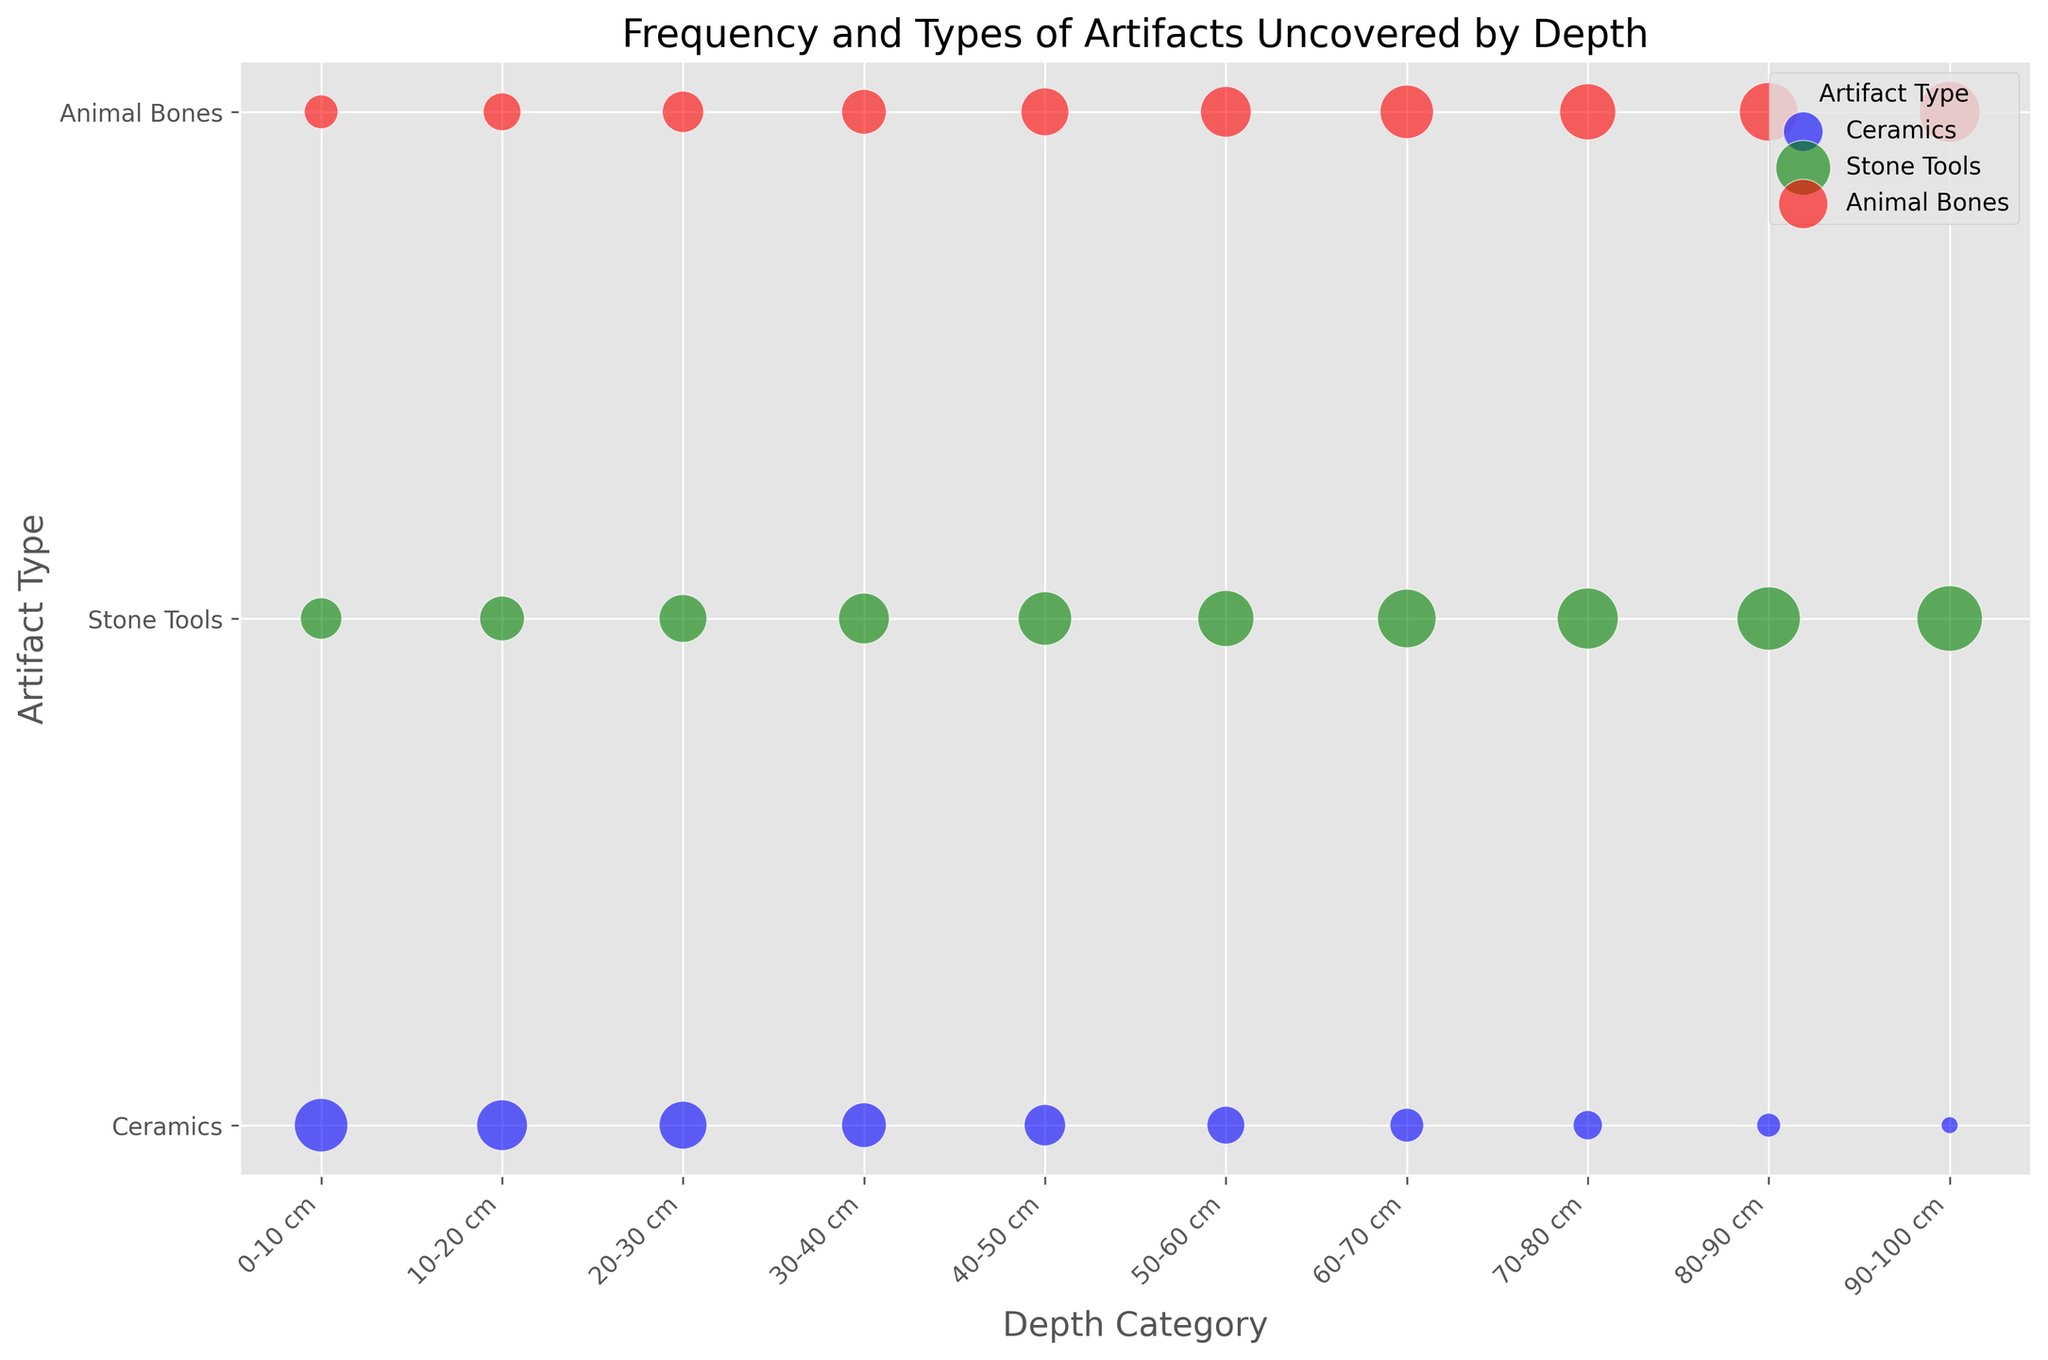Which artifact type is found most frequently in the 90-100 cm depth category? By observing the size of the bubbles, the Stone Tools have the largest bubble within the depth category of 90-100 cm which implies the highest frequency.
Answer: Stone Tools Which depth category shows an equal frequency of Ceramics and Animal Bones? For the 30-40 cm depth category, the size of the bubbles for Ceramics and Animal Bones are the same.
Answer: 30-40 cm What is the difference in frequency between Stone Tools and Ceramics in the 60-70 cm depth category? The frequency of Stone Tools at 60-70 cm is represented by the size of the bubble, which is larger in comparison to Ceramics. Stone Tools frequency is 60 and Ceramics is 20, difference being 60 - 20.
Answer: 40 What is the total frequency of Animal Bones in the depths 0-10 cm and 10-20 cm combined? Add the frequencies of Animal Bones in these two categories: 20 from 0-10 cm and 25 from 10-20 cm. So, 20 + 25 = 45.
Answer: 45 Which depth category has the largest frequency disparity between Stone Tools and Animal Bones? By comparing all depth categories, the largest disparity is seen in the 90-100 cm category where Stone Tools frequency (75) is significantly higher than Animal Bones frequency (65). The difference is 75 - 65 = 10.
Answer: 90-100 cm How does the frequency of Stone Tools change with increasing depth? Observe the size of Stone Tools bubbles across depth categories (0-10 cm to 90-100 cm). They increase consistently, suggesting a rising trend in frequency.
Answer: Increases Which artifact type shows the least change in frequency across different depths? By visual inspection, Ceramics' bubble sizes have less fluctuation compared to Stone Tools and Animal Bones across all depth categories.
Answer: Ceramics At what depth category is the frequency of Ceramics exactly half of the frequency of Stone Tools? In the 70-80 cm depth category, Ceramics frequency is 15 and Stone Tools frequency is 65, and 15 is half of 30, so 30-60 cm is the depth category where it holds true.
Answer: 70-80 cm 